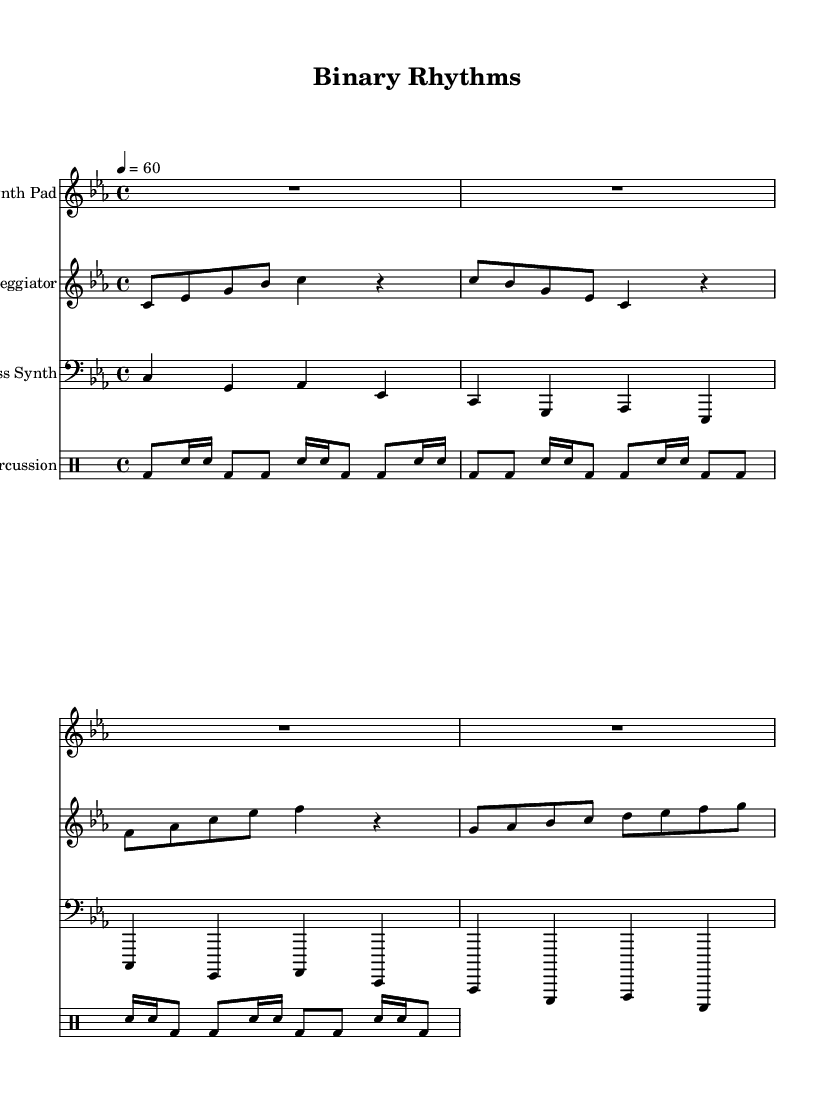What is the key signature of this music? The key signature indicated in the score is C minor, which consists of three flats (B flat, E flat, and A flat). This is found at the beginning of the staff.
Answer: C minor What is the time signature of this music? The time signature shown in the score is 4/4, which means there are four beats in each measure and that a quarter note gets one beat. This is indicated at the beginning of the score.
Answer: 4/4 What is the tempo marking for this piece? The tempo marking in the score indicates a beat of 60 beats per minute, as shown next to the "tempo" instruction. This specifies how fast the music should be played.
Answer: 60 How many instruments are used in this piece? The score indicates four different instruments: a Synth Pad, an Arpeggiator, a Bass Synth, and a Glitch Percussion section. Each one is clearly labeled in the score.
Answer: Four What rhythmic pattern does the Glitch Percussion utilize? The Glitch Percussion part consists primarily of a bass drum (bd) and snare (sn) in a repeating pattern of eighth and sixteenth notes. This is visible in the drum notation under the text "glitchPercussion."
Answer: Bass and snare Which instrument plays the arpeggiator part? The arpeggiator is played on a synthesizer, as inferred from the instrument name indicated above its musical staff. This indicates the type of sound being produced.
Answer: Synthesizer What style of music does this piece represent? The music is ambient electronic, as indicated by the title "Binary Rhythms" and the overall atmospheric character of the instrumentation and arrangement. This style emphasizes mood and atmosphere over traditional melodic structures.
Answer: Ambient electronic 